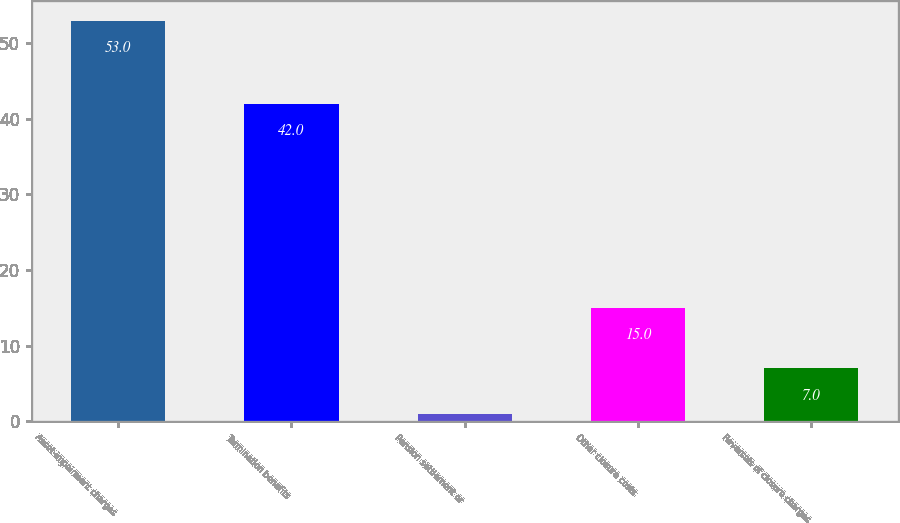Convert chart. <chart><loc_0><loc_0><loc_500><loc_500><bar_chart><fcel>Asset-impairment charges<fcel>Termination benefits<fcel>Pension settlement or<fcel>Other closure costs<fcel>Reversals of closure charges<nl><fcel>53<fcel>42<fcel>1<fcel>15<fcel>7<nl></chart> 